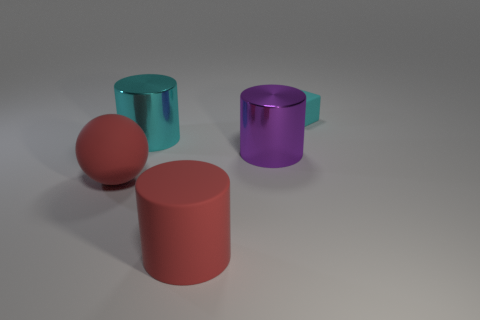Subtract all gray cubes. Subtract all cyan spheres. How many cubes are left? 1 Add 4 large purple shiny things. How many objects exist? 9 Subtract all blocks. How many objects are left? 4 Add 2 cyan blocks. How many cyan blocks exist? 3 Subtract 0 brown cylinders. How many objects are left? 5 Subtract all rubber things. Subtract all tiny purple rubber balls. How many objects are left? 2 Add 2 big cyan metallic cylinders. How many big cyan metallic cylinders are left? 3 